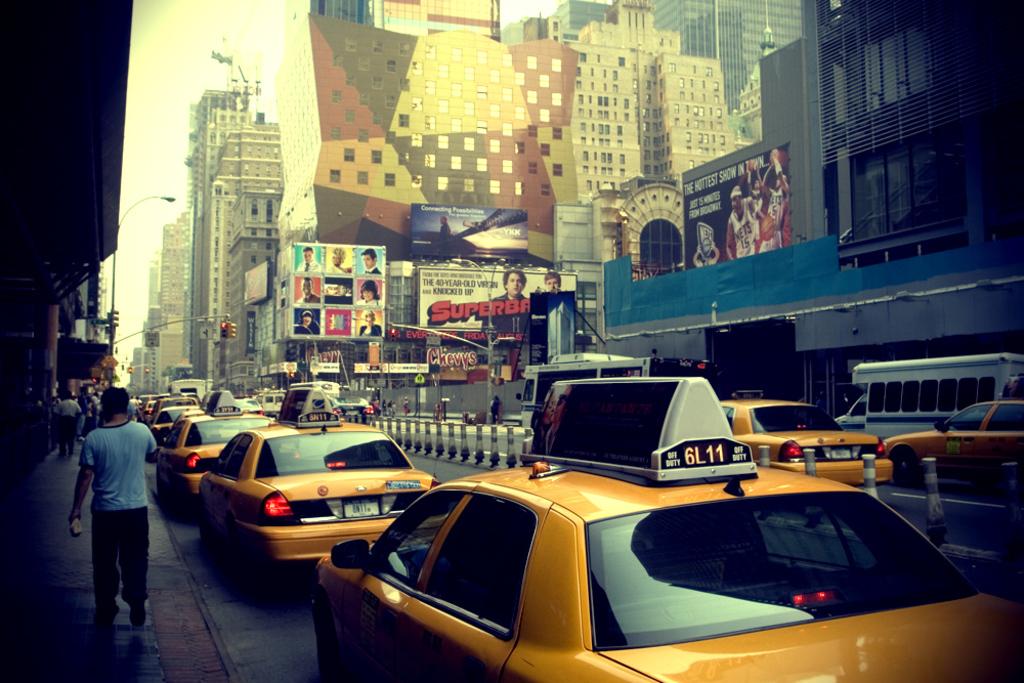Is superbad advertised here?
Offer a terse response. Yes. 